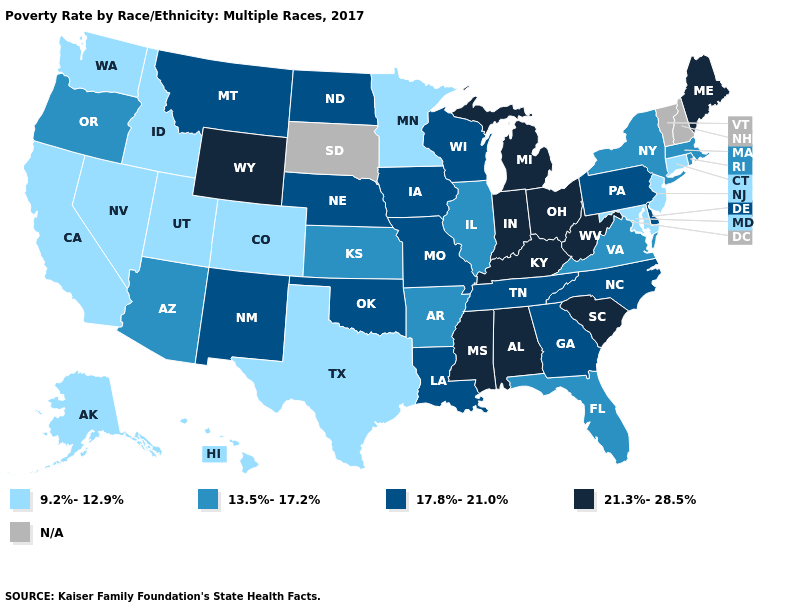Which states have the lowest value in the Northeast?
Give a very brief answer. Connecticut, New Jersey. What is the lowest value in states that border Kentucky?
Give a very brief answer. 13.5%-17.2%. Among the states that border Georgia , does South Carolina have the highest value?
Be succinct. Yes. What is the value of Florida?
Short answer required. 13.5%-17.2%. Which states have the lowest value in the USA?
Give a very brief answer. Alaska, California, Colorado, Connecticut, Hawaii, Idaho, Maryland, Minnesota, Nevada, New Jersey, Texas, Utah, Washington. Does Texas have the lowest value in the South?
Keep it brief. Yes. How many symbols are there in the legend?
Short answer required. 5. What is the value of Tennessee?
Keep it brief. 17.8%-21.0%. Name the states that have a value in the range 21.3%-28.5%?
Write a very short answer. Alabama, Indiana, Kentucky, Maine, Michigan, Mississippi, Ohio, South Carolina, West Virginia, Wyoming. Does the map have missing data?
Write a very short answer. Yes. Name the states that have a value in the range 21.3%-28.5%?
Short answer required. Alabama, Indiana, Kentucky, Maine, Michigan, Mississippi, Ohio, South Carolina, West Virginia, Wyoming. What is the value of Maryland?
Short answer required. 9.2%-12.9%. Among the states that border New Hampshire , does Maine have the highest value?
Be succinct. Yes. 